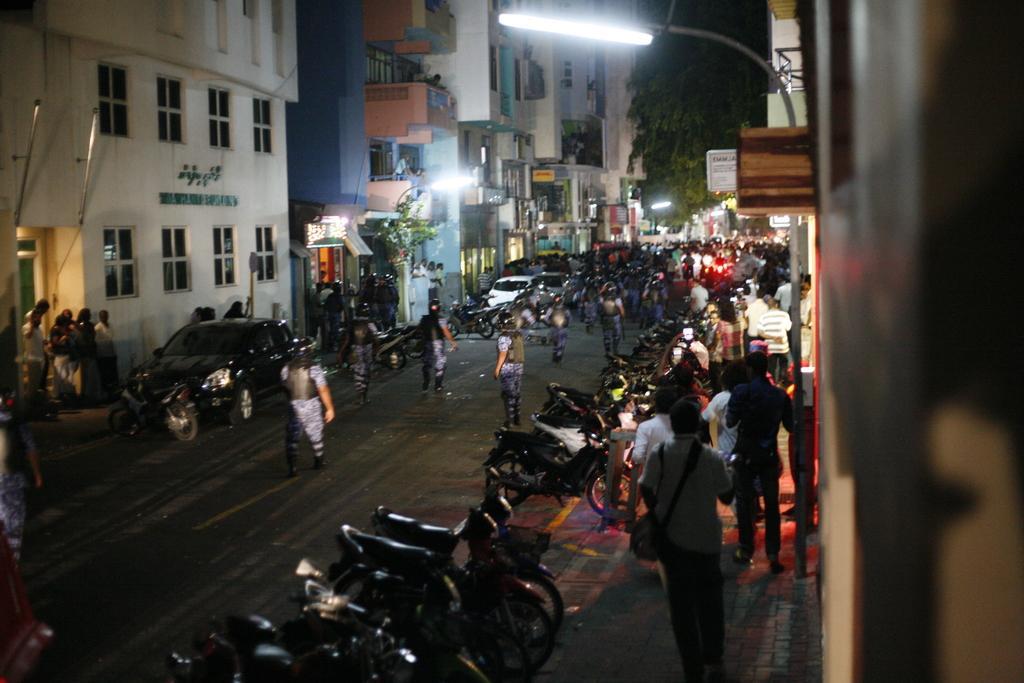In one or two sentences, can you explain what this image depicts? This picture shows few buildings and a tree and we see a pole light on the sidewalk and we see people standing on the road and sidewalk and we see motorcycles parked and few cars on the side and we see few lights. 